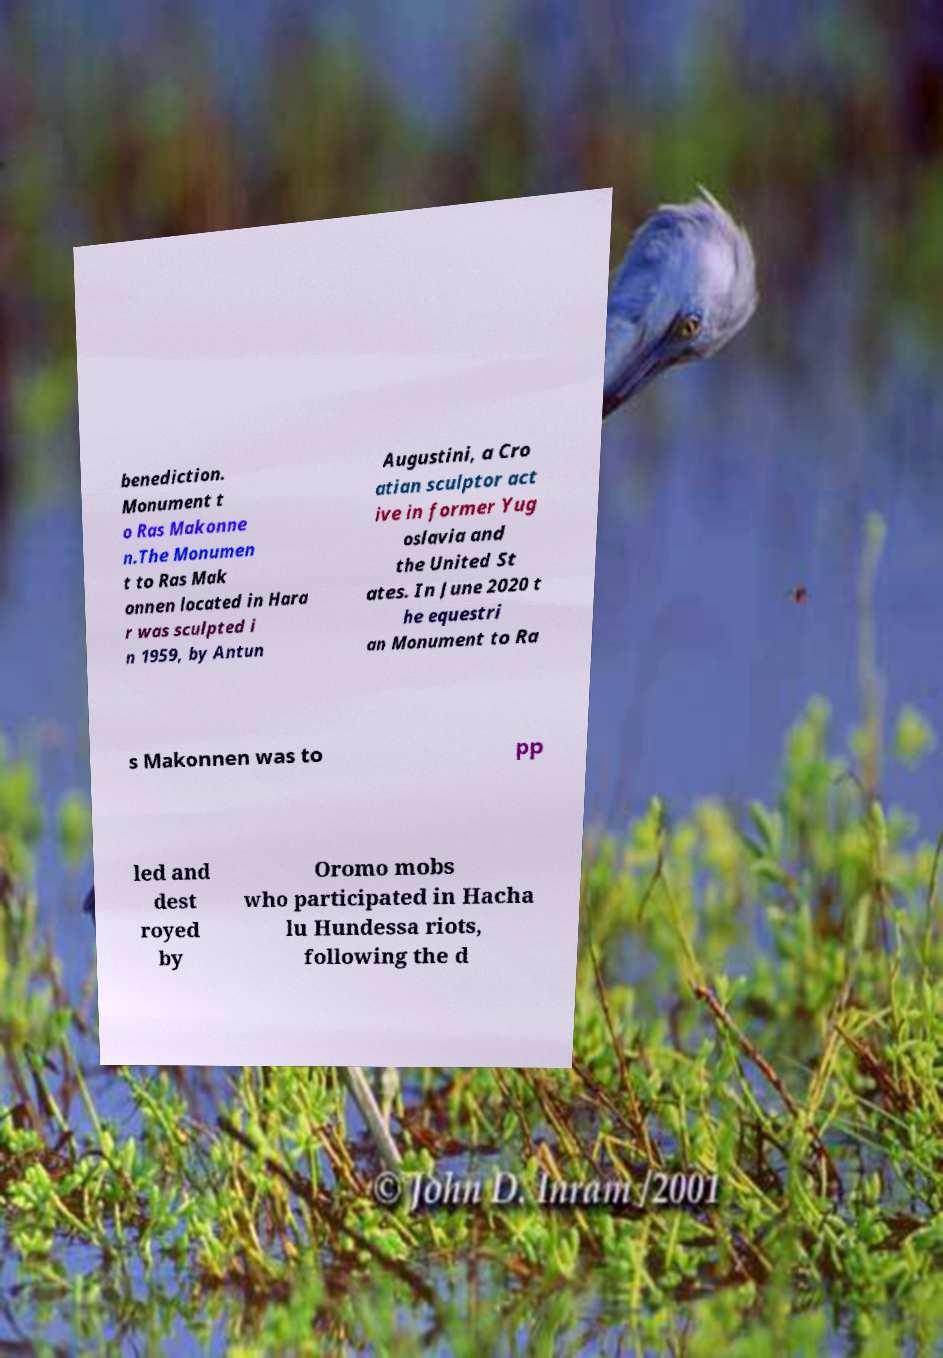There's text embedded in this image that I need extracted. Can you transcribe it verbatim? benediction. Monument t o Ras Makonne n.The Monumen t to Ras Mak onnen located in Hara r was sculpted i n 1959, by Antun Augustini, a Cro atian sculptor act ive in former Yug oslavia and the United St ates. In June 2020 t he equestri an Monument to Ra s Makonnen was to pp led and dest royed by Oromo mobs who participated in Hacha lu Hundessa riots, following the d 